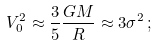<formula> <loc_0><loc_0><loc_500><loc_500>V _ { 0 } ^ { 2 } \approx \frac { 3 } { 5 } \frac { G M } { R } \approx 3 \sigma ^ { 2 } \, ;</formula> 